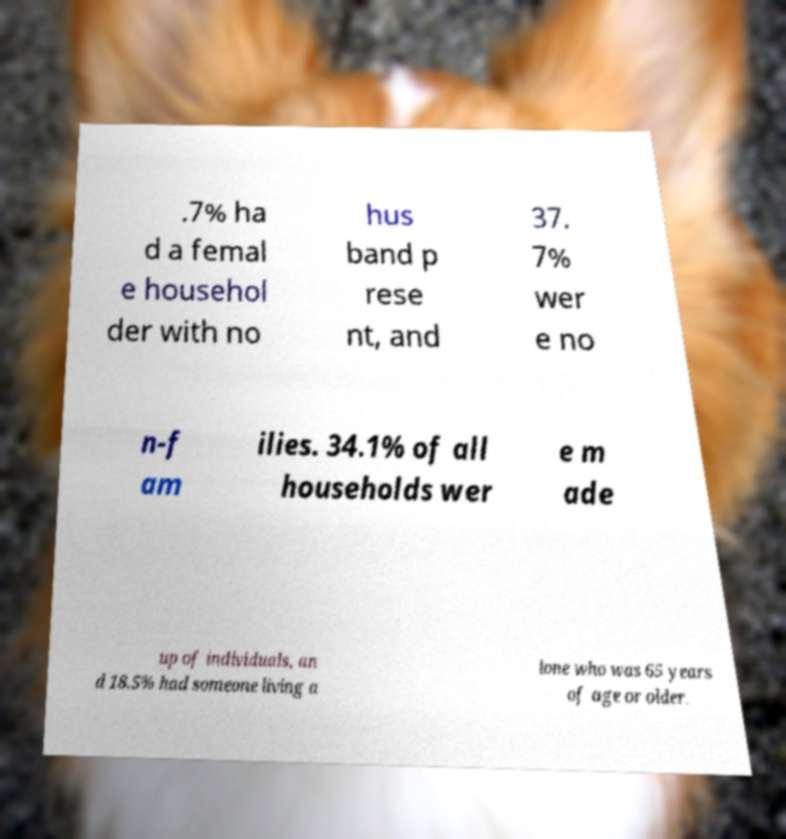Could you extract and type out the text from this image? .7% ha d a femal e househol der with no hus band p rese nt, and 37. 7% wer e no n-f am ilies. 34.1% of all households wer e m ade up of individuals, an d 18.5% had someone living a lone who was 65 years of age or older. 